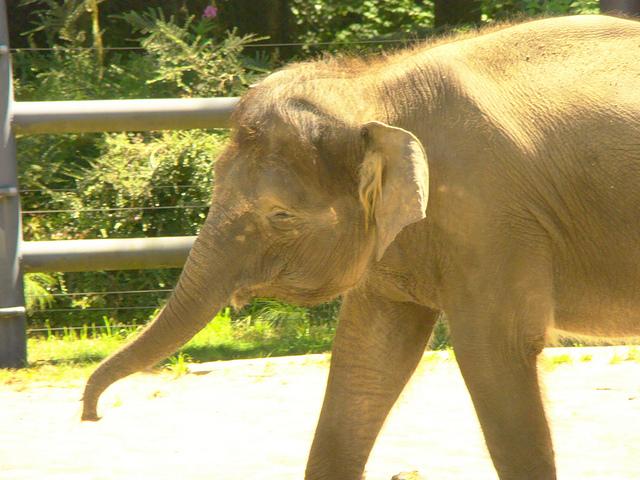Is this a boy or a girl elephant?
Keep it brief. Girl. Is the elephant at the zoo?
Short answer required. Yes. Is this an adult elephant?
Write a very short answer. No. 